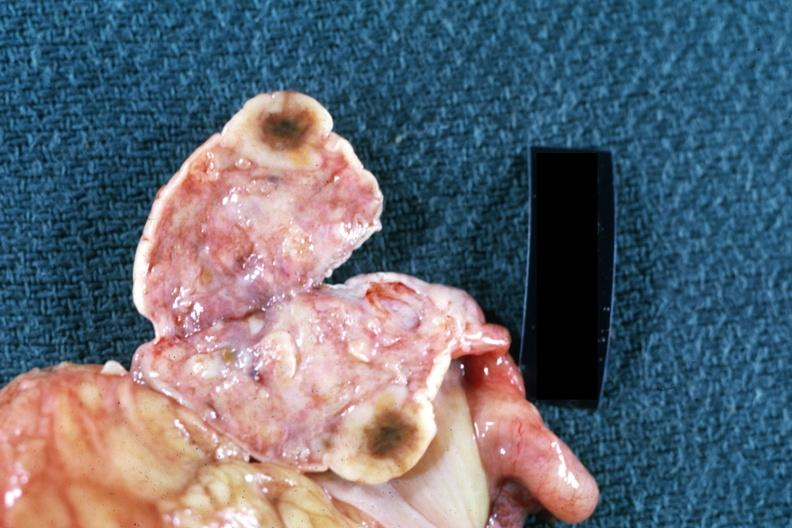what is present?
Answer the question using a single word or phrase. Metastatic carcinoma 